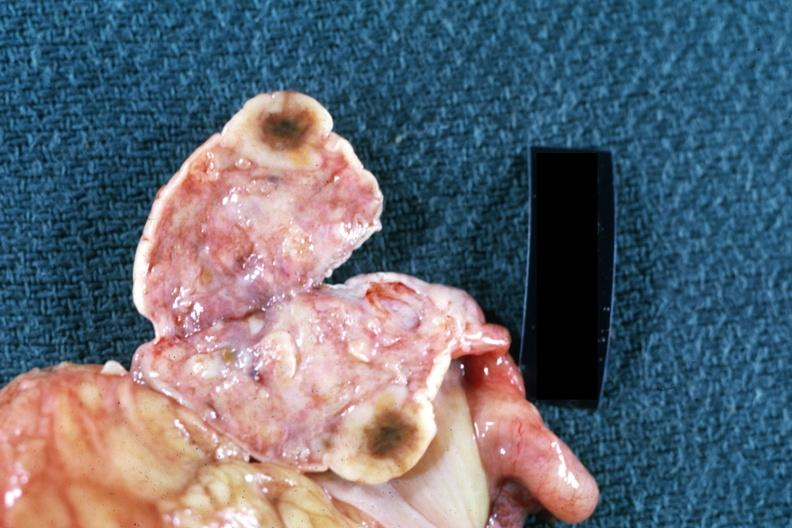what is present?
Answer the question using a single word or phrase. Metastatic carcinoma 